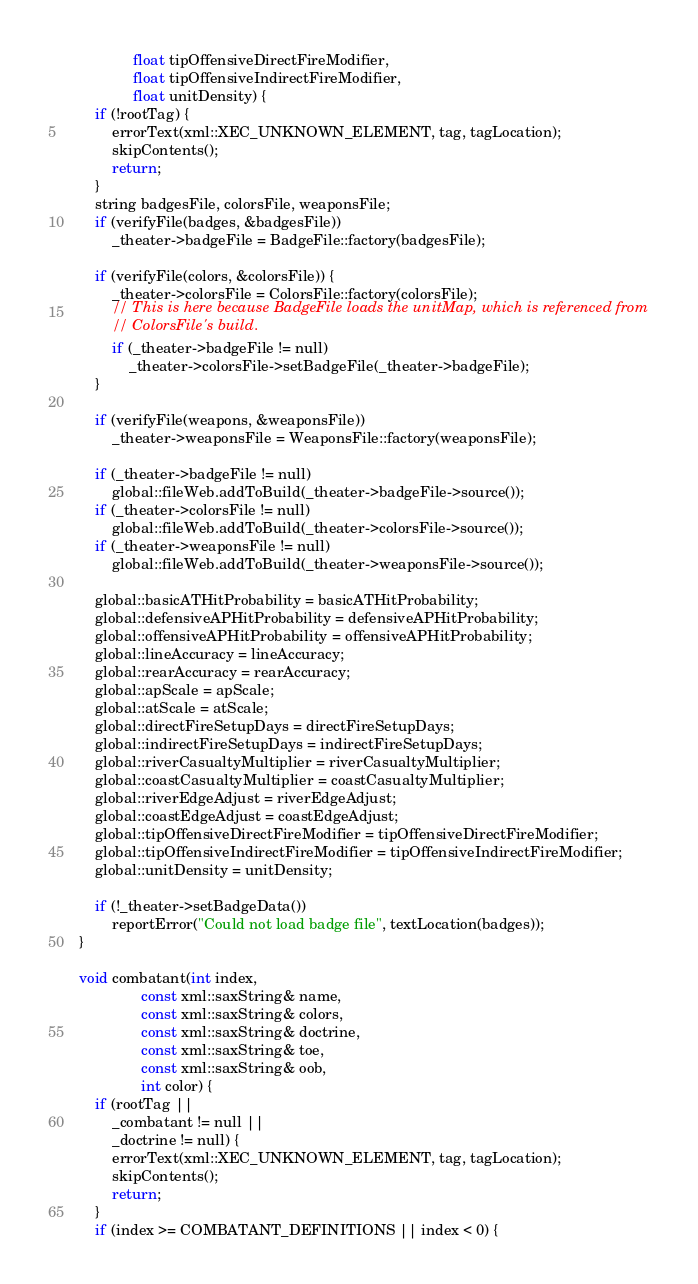<code> <loc_0><loc_0><loc_500><loc_500><_C++_>				 float tipOffensiveDirectFireModifier,
				 float tipOffensiveIndirectFireModifier,
				 float unitDensity) {
		if (!rootTag) {
			errorText(xml::XEC_UNKNOWN_ELEMENT, tag, tagLocation);
			skipContents();
			return;
		}
		string badgesFile, colorsFile, weaponsFile;
		if (verifyFile(badges, &badgesFile))
			_theater->badgeFile = BadgeFile::factory(badgesFile);

		if (verifyFile(colors, &colorsFile)) {
			_theater->colorsFile = ColorsFile::factory(colorsFile);
			// This is here because BadgeFile loads the unitMap, which is referenced from
			// ColorsFile's build.
			if (_theater->badgeFile != null)
				_theater->colorsFile->setBadgeFile(_theater->badgeFile);
		}

		if (verifyFile(weapons, &weaponsFile)) 
			_theater->weaponsFile = WeaponsFile::factory(weaponsFile);

		if (_theater->badgeFile != null)
			global::fileWeb.addToBuild(_theater->badgeFile->source());
		if (_theater->colorsFile != null)
			global::fileWeb.addToBuild(_theater->colorsFile->source());
		if (_theater->weaponsFile != null)
			global::fileWeb.addToBuild(_theater->weaponsFile->source());

		global::basicATHitProbability = basicATHitProbability;
		global::defensiveAPHitProbability = defensiveAPHitProbability;
		global::offensiveAPHitProbability = offensiveAPHitProbability;
		global::lineAccuracy = lineAccuracy;
		global::rearAccuracy = rearAccuracy;
		global::apScale = apScale;
		global::atScale = atScale;
		global::directFireSetupDays = directFireSetupDays;
		global::indirectFireSetupDays = indirectFireSetupDays;
		global::riverCasualtyMultiplier = riverCasualtyMultiplier;
		global::coastCasualtyMultiplier = coastCasualtyMultiplier;
		global::riverEdgeAdjust = riverEdgeAdjust;
		global::coastEdgeAdjust = coastEdgeAdjust;
		global::tipOffensiveDirectFireModifier = tipOffensiveDirectFireModifier;
		global::tipOffensiveIndirectFireModifier = tipOffensiveIndirectFireModifier;
		global::unitDensity = unitDensity;

		if (!_theater->setBadgeData())
			reportError("Could not load badge file", textLocation(badges));
 	}

	void combatant(int index,
				   const xml::saxString& name,
				   const xml::saxString& colors,
				   const xml::saxString& doctrine,
				   const xml::saxString& toe,
				   const xml::saxString& oob,
				   int color) {
		if (rootTag ||
			_combatant != null ||
			_doctrine != null) {
			errorText(xml::XEC_UNKNOWN_ELEMENT, tag, tagLocation);
			skipContents();
			return;
		}
		if (index >= COMBATANT_DEFINITIONS || index < 0) {</code> 